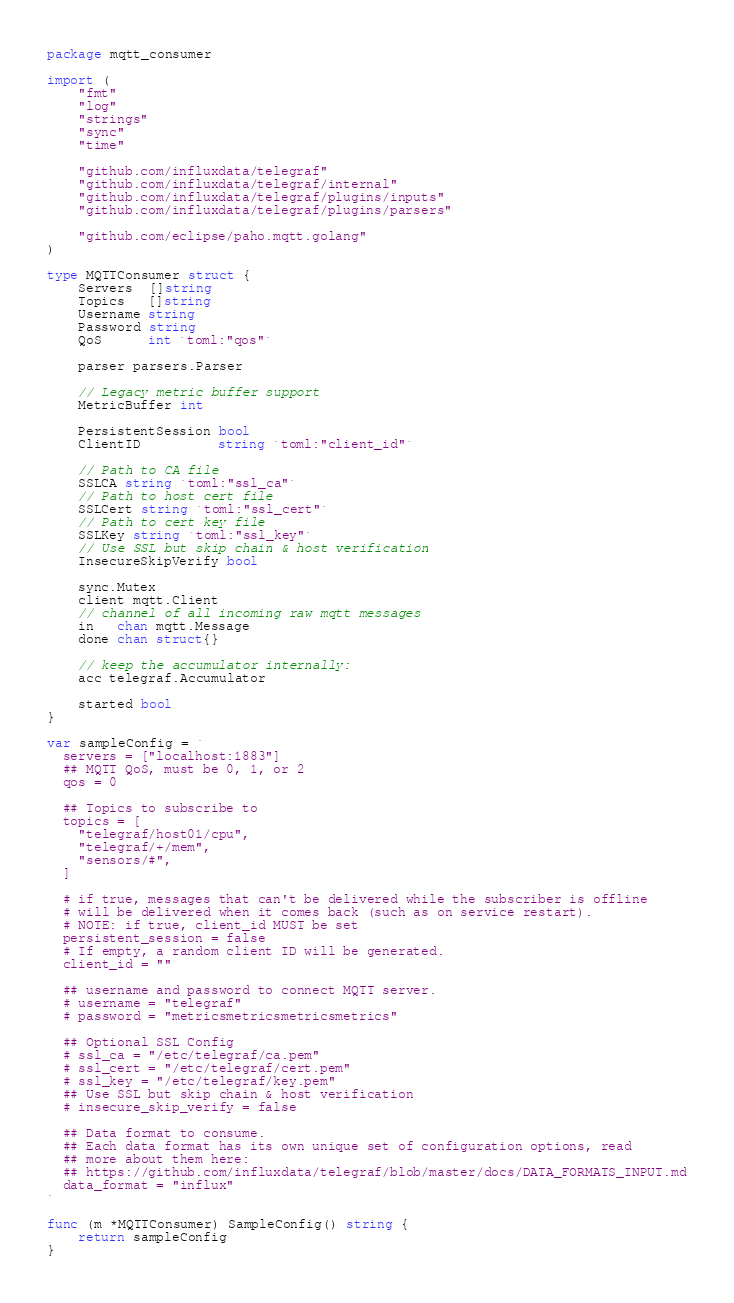Convert code to text. <code><loc_0><loc_0><loc_500><loc_500><_Go_>package mqtt_consumer

import (
	"fmt"
	"log"
	"strings"
	"sync"
	"time"

	"github.com/influxdata/telegraf"
	"github.com/influxdata/telegraf/internal"
	"github.com/influxdata/telegraf/plugins/inputs"
	"github.com/influxdata/telegraf/plugins/parsers"

	"github.com/eclipse/paho.mqtt.golang"
)

type MQTTConsumer struct {
	Servers  []string
	Topics   []string
	Username string
	Password string
	QoS      int `toml:"qos"`

	parser parsers.Parser

	// Legacy metric buffer support
	MetricBuffer int

	PersistentSession bool
	ClientID          string `toml:"client_id"`

	// Path to CA file
	SSLCA string `toml:"ssl_ca"`
	// Path to host cert file
	SSLCert string `toml:"ssl_cert"`
	// Path to cert key file
	SSLKey string `toml:"ssl_key"`
	// Use SSL but skip chain & host verification
	InsecureSkipVerify bool

	sync.Mutex
	client mqtt.Client
	// channel of all incoming raw mqtt messages
	in   chan mqtt.Message
	done chan struct{}

	// keep the accumulator internally:
	acc telegraf.Accumulator

	started bool
}

var sampleConfig = `
  servers = ["localhost:1883"]
  ## MQTT QoS, must be 0, 1, or 2
  qos = 0

  ## Topics to subscribe to
  topics = [
    "telegraf/host01/cpu",
    "telegraf/+/mem",
    "sensors/#",
  ]

  # if true, messages that can't be delivered while the subscriber is offline
  # will be delivered when it comes back (such as on service restart).
  # NOTE: if true, client_id MUST be set
  persistent_session = false
  # If empty, a random client ID will be generated.
  client_id = ""

  ## username and password to connect MQTT server.
  # username = "telegraf"
  # password = "metricsmetricsmetricsmetrics"

  ## Optional SSL Config
  # ssl_ca = "/etc/telegraf/ca.pem"
  # ssl_cert = "/etc/telegraf/cert.pem"
  # ssl_key = "/etc/telegraf/key.pem"
  ## Use SSL but skip chain & host verification
  # insecure_skip_verify = false

  ## Data format to consume.
  ## Each data format has its own unique set of configuration options, read
  ## more about them here:
  ## https://github.com/influxdata/telegraf/blob/master/docs/DATA_FORMATS_INPUT.md
  data_format = "influx"
`

func (m *MQTTConsumer) SampleConfig() string {
	return sampleConfig
}
</code> 